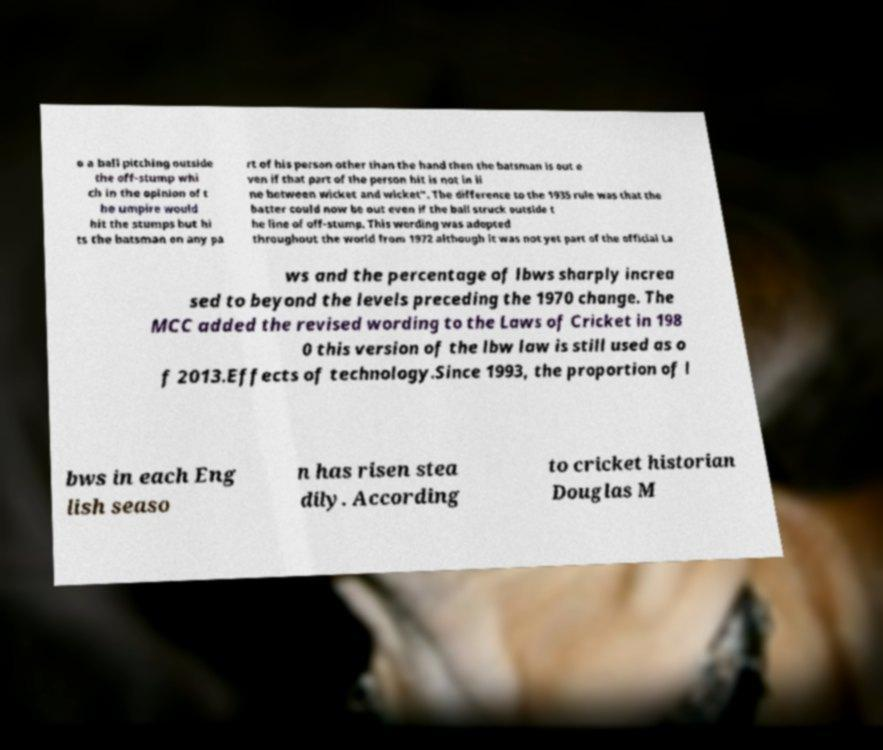I need the written content from this picture converted into text. Can you do that? o a ball pitching outside the off-stump whi ch in the opinion of t he umpire would hit the stumps but hi ts the batsman on any pa rt of his person other than the hand then the batsman is out e ven if that part of the person hit is not in li ne between wicket and wicket". The difference to the 1935 rule was that the batter could now be out even if the ball struck outside t he line of off-stump. This wording was adopted throughout the world from 1972 although it was not yet part of the official La ws and the percentage of lbws sharply increa sed to beyond the levels preceding the 1970 change. The MCC added the revised wording to the Laws of Cricket in 198 0 this version of the lbw law is still used as o f 2013.Effects of technology.Since 1993, the proportion of l bws in each Eng lish seaso n has risen stea dily. According to cricket historian Douglas M 